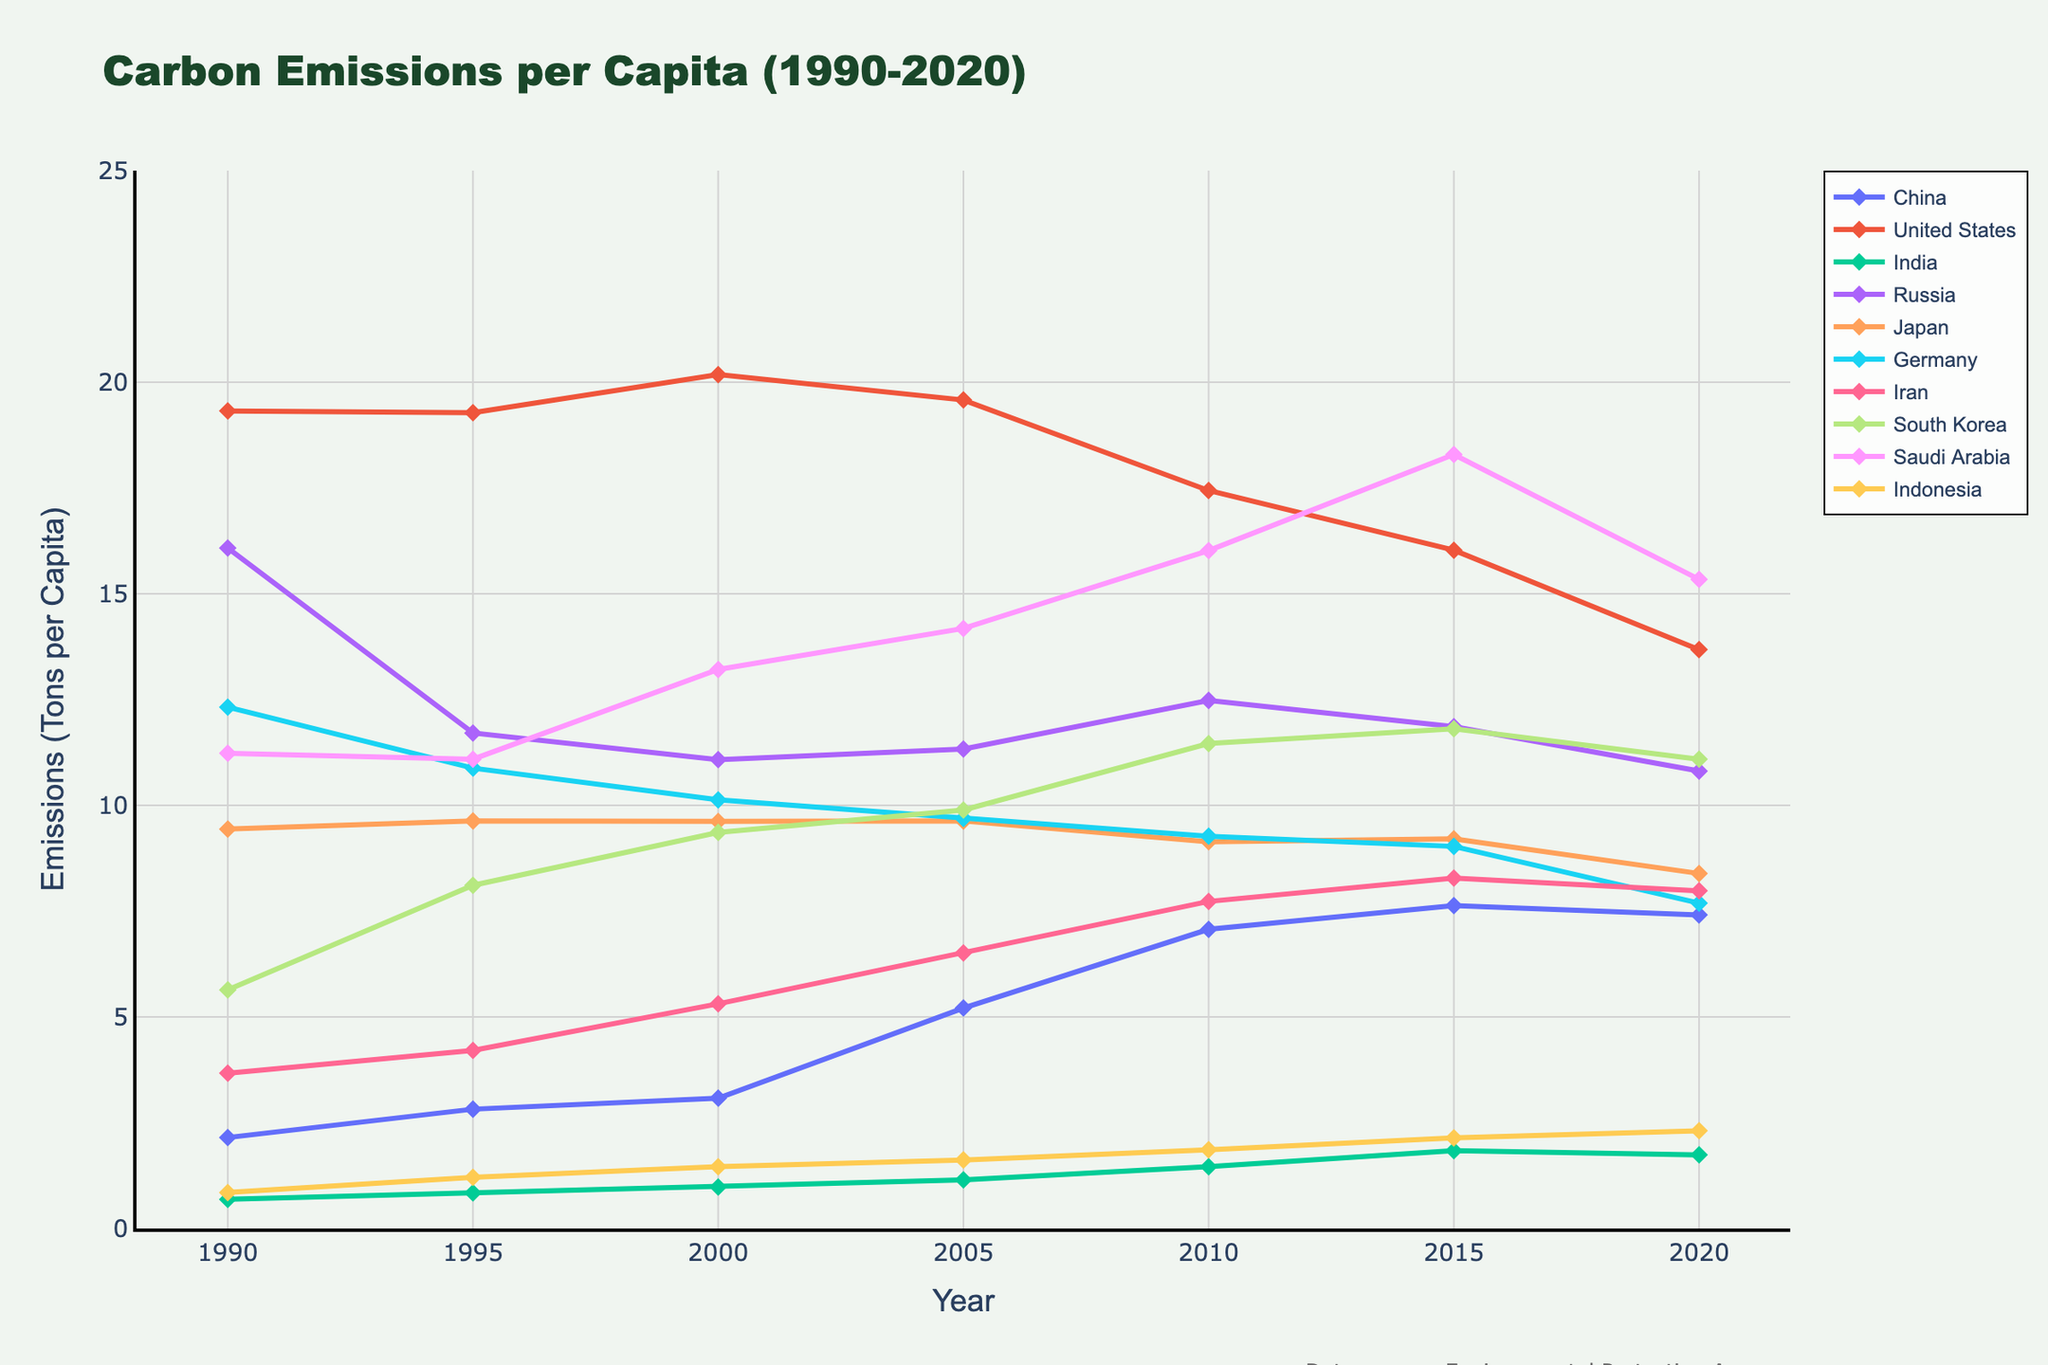Which country had the highest carbon emissions per capita in 2000? Look at the y-values (emissions) for each country in the year 2000 and find the highest one. Saudi Arabia has the highest value in 2000 (13.21).
Answer: Saudi Arabia By how much did carbon emissions per capita in China increase from 1990 to 2020? To find the increase, subtract China's 1990 emissions from the 2020 emissions. The calculation is 7.41 - 2.15.
Answer: 5.26 Which country showed a decrease in carbon emissions per capita from 2015 to 2020? Check the trend lines for each country between 2015 and 2020 to see if they go downward. Germany and Saudi Arabia show decreases during that period.
Answer: Germany and Saudi Arabia Among the top 10 polluting countries, which country had the lowest carbon emissions per capita in 2010? Compare the y-values for each country in 2010 and find the lowest one. India's value in 2010 is the lowest (1.46).
Answer: India What is the difference between carbon emissions per capita for the United States and Japan in 2020? Subtract Japan’s emissions in 2020 from the United States' emissions in 2020. The calculation is 13.68 - 8.39.
Answer: 5.29 Which countries' carbon emissions per capita were around 7 tons in 2020? Look for countries where the y-values in 2020 are approximately equal to 7. China (7.41), Germany (7.69), and Iran (7.98) are around 7 tons.
Answer: China, Germany, Iran Did India’s carbon emissions per capita ever exceed 2 tons between 1990 and 2020? Check the trend line for India to see if it surpasses the 2-ton mark at any point. India's emissions do not exceed 2 tons within this time range.
Answer: No Which country had the steepest increase in carbon emissions per capita between 1990 and 2005? To find the steepest increase, compare the slopes of the lines for each country over this period. China has the steepest slope.
Answer: China How did Russia's carbon emissions per capita change from 1995 to 2010? Observe the trend line for Russia between 1995 and 2010. It first decreases from 1995 to 2000, then increases from 2000 to 2010.
Answer: Decreased and then increased In 2015, which country had a carbon emissions per capita value closer to Iran's 2015 value? Compare all countries' 2015 emissions to Iran’s 2015 value (8.28). South Korea (11.81) is relatively close.
Answer: South Korea 